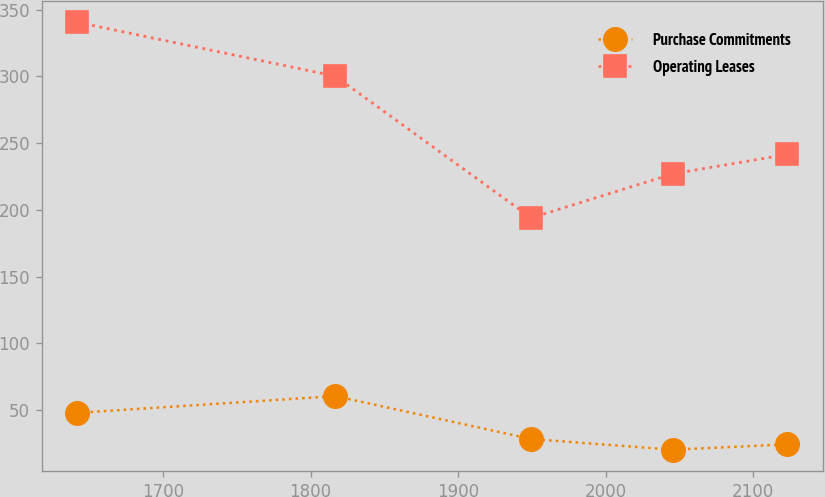Convert chart. <chart><loc_0><loc_0><loc_500><loc_500><line_chart><ecel><fcel>Purchase Commitments<fcel>Operating Leases<nl><fcel>1641.97<fcel>47.9<fcel>340.6<nl><fcel>1816.73<fcel>60.44<fcel>300.22<nl><fcel>1949.51<fcel>28.3<fcel>193.98<nl><fcel>2045.34<fcel>20.26<fcel>226.94<nl><fcel>2123.06<fcel>24.28<fcel>241.6<nl></chart> 